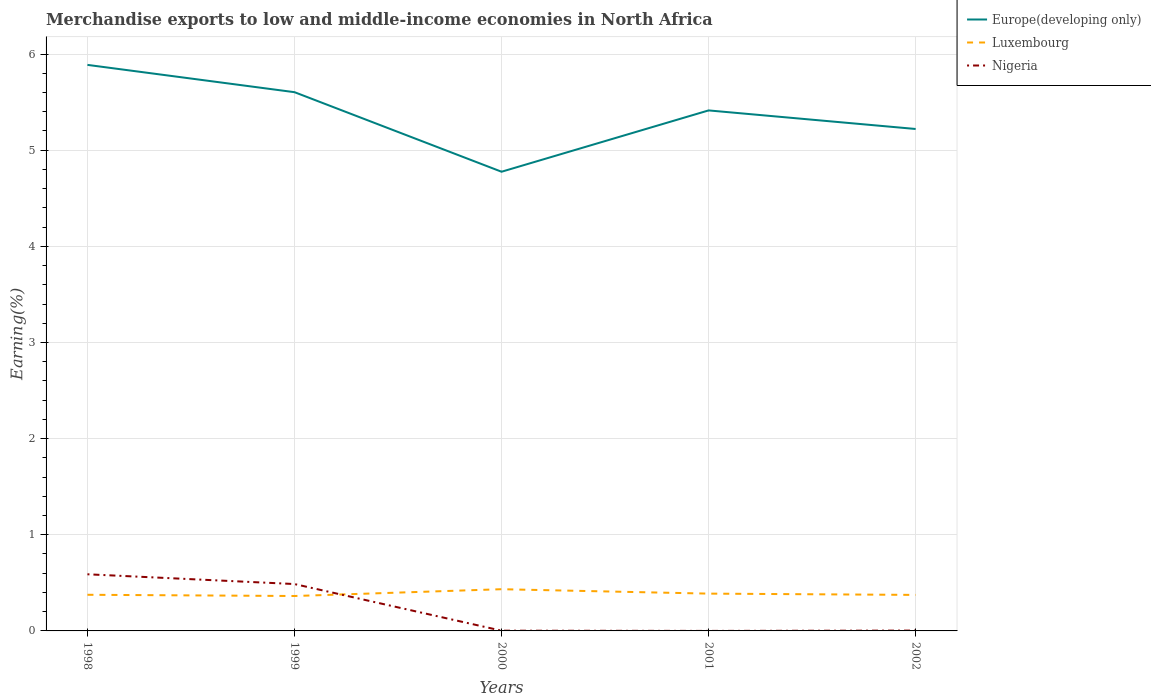How many different coloured lines are there?
Offer a terse response. 3. Is the number of lines equal to the number of legend labels?
Keep it short and to the point. Yes. Across all years, what is the maximum percentage of amount earned from merchandise exports in Luxembourg?
Provide a succinct answer. 0.36. In which year was the percentage of amount earned from merchandise exports in Luxembourg maximum?
Ensure brevity in your answer.  1999. What is the total percentage of amount earned from merchandise exports in Europe(developing only) in the graph?
Offer a terse response. -0.64. What is the difference between the highest and the second highest percentage of amount earned from merchandise exports in Europe(developing only)?
Your response must be concise. 1.11. Is the percentage of amount earned from merchandise exports in Luxembourg strictly greater than the percentage of amount earned from merchandise exports in Nigeria over the years?
Offer a very short reply. No. How many lines are there?
Offer a terse response. 3. What is the difference between two consecutive major ticks on the Y-axis?
Offer a terse response. 1. Are the values on the major ticks of Y-axis written in scientific E-notation?
Keep it short and to the point. No. Does the graph contain any zero values?
Provide a succinct answer. No. How many legend labels are there?
Keep it short and to the point. 3. How are the legend labels stacked?
Provide a succinct answer. Vertical. What is the title of the graph?
Make the answer very short. Merchandise exports to low and middle-income economies in North Africa. Does "High income" appear as one of the legend labels in the graph?
Offer a very short reply. No. What is the label or title of the Y-axis?
Give a very brief answer. Earning(%). What is the Earning(%) of Europe(developing only) in 1998?
Ensure brevity in your answer.  5.89. What is the Earning(%) of Luxembourg in 1998?
Give a very brief answer. 0.38. What is the Earning(%) in Nigeria in 1998?
Offer a terse response. 0.59. What is the Earning(%) in Europe(developing only) in 1999?
Your answer should be compact. 5.6. What is the Earning(%) of Luxembourg in 1999?
Make the answer very short. 0.36. What is the Earning(%) of Nigeria in 1999?
Provide a short and direct response. 0.49. What is the Earning(%) of Europe(developing only) in 2000?
Your answer should be compact. 4.78. What is the Earning(%) in Luxembourg in 2000?
Make the answer very short. 0.43. What is the Earning(%) in Nigeria in 2000?
Offer a terse response. 0. What is the Earning(%) in Europe(developing only) in 2001?
Offer a terse response. 5.41. What is the Earning(%) of Luxembourg in 2001?
Make the answer very short. 0.39. What is the Earning(%) in Nigeria in 2001?
Your response must be concise. 9.03093325320677e-5. What is the Earning(%) of Europe(developing only) in 2002?
Your response must be concise. 5.22. What is the Earning(%) in Luxembourg in 2002?
Give a very brief answer. 0.37. What is the Earning(%) in Nigeria in 2002?
Provide a short and direct response. 0. Across all years, what is the maximum Earning(%) of Europe(developing only)?
Make the answer very short. 5.89. Across all years, what is the maximum Earning(%) in Luxembourg?
Your answer should be compact. 0.43. Across all years, what is the maximum Earning(%) of Nigeria?
Ensure brevity in your answer.  0.59. Across all years, what is the minimum Earning(%) of Europe(developing only)?
Your answer should be compact. 4.78. Across all years, what is the minimum Earning(%) of Luxembourg?
Offer a terse response. 0.36. Across all years, what is the minimum Earning(%) of Nigeria?
Provide a succinct answer. 9.03093325320677e-5. What is the total Earning(%) in Europe(developing only) in the graph?
Your response must be concise. 26.9. What is the total Earning(%) in Luxembourg in the graph?
Provide a short and direct response. 1.94. What is the total Earning(%) in Nigeria in the graph?
Ensure brevity in your answer.  1.08. What is the difference between the Earning(%) of Europe(developing only) in 1998 and that in 1999?
Your answer should be very brief. 0.28. What is the difference between the Earning(%) in Luxembourg in 1998 and that in 1999?
Your response must be concise. 0.01. What is the difference between the Earning(%) in Nigeria in 1998 and that in 1999?
Ensure brevity in your answer.  0.1. What is the difference between the Earning(%) in Europe(developing only) in 1998 and that in 2000?
Offer a terse response. 1.11. What is the difference between the Earning(%) of Luxembourg in 1998 and that in 2000?
Your response must be concise. -0.06. What is the difference between the Earning(%) of Nigeria in 1998 and that in 2000?
Make the answer very short. 0.59. What is the difference between the Earning(%) of Europe(developing only) in 1998 and that in 2001?
Your response must be concise. 0.47. What is the difference between the Earning(%) of Luxembourg in 1998 and that in 2001?
Keep it short and to the point. -0.01. What is the difference between the Earning(%) in Nigeria in 1998 and that in 2001?
Provide a short and direct response. 0.59. What is the difference between the Earning(%) of Luxembourg in 1998 and that in 2002?
Give a very brief answer. 0. What is the difference between the Earning(%) in Nigeria in 1998 and that in 2002?
Give a very brief answer. 0.59. What is the difference between the Earning(%) of Europe(developing only) in 1999 and that in 2000?
Provide a succinct answer. 0.83. What is the difference between the Earning(%) of Luxembourg in 1999 and that in 2000?
Give a very brief answer. -0.07. What is the difference between the Earning(%) in Nigeria in 1999 and that in 2000?
Make the answer very short. 0.49. What is the difference between the Earning(%) of Europe(developing only) in 1999 and that in 2001?
Provide a succinct answer. 0.19. What is the difference between the Earning(%) of Luxembourg in 1999 and that in 2001?
Your answer should be compact. -0.02. What is the difference between the Earning(%) in Nigeria in 1999 and that in 2001?
Ensure brevity in your answer.  0.49. What is the difference between the Earning(%) in Europe(developing only) in 1999 and that in 2002?
Provide a succinct answer. 0.38. What is the difference between the Earning(%) of Luxembourg in 1999 and that in 2002?
Offer a terse response. -0.01. What is the difference between the Earning(%) of Nigeria in 1999 and that in 2002?
Give a very brief answer. 0.48. What is the difference between the Earning(%) of Europe(developing only) in 2000 and that in 2001?
Make the answer very short. -0.64. What is the difference between the Earning(%) of Luxembourg in 2000 and that in 2001?
Your response must be concise. 0.05. What is the difference between the Earning(%) of Nigeria in 2000 and that in 2001?
Provide a succinct answer. 0. What is the difference between the Earning(%) in Europe(developing only) in 2000 and that in 2002?
Your response must be concise. -0.44. What is the difference between the Earning(%) in Luxembourg in 2000 and that in 2002?
Offer a terse response. 0.06. What is the difference between the Earning(%) of Nigeria in 2000 and that in 2002?
Keep it short and to the point. -0. What is the difference between the Earning(%) of Europe(developing only) in 2001 and that in 2002?
Provide a short and direct response. 0.19. What is the difference between the Earning(%) of Luxembourg in 2001 and that in 2002?
Offer a terse response. 0.01. What is the difference between the Earning(%) in Nigeria in 2001 and that in 2002?
Keep it short and to the point. -0. What is the difference between the Earning(%) in Europe(developing only) in 1998 and the Earning(%) in Luxembourg in 1999?
Provide a short and direct response. 5.52. What is the difference between the Earning(%) of Europe(developing only) in 1998 and the Earning(%) of Nigeria in 1999?
Offer a terse response. 5.4. What is the difference between the Earning(%) of Luxembourg in 1998 and the Earning(%) of Nigeria in 1999?
Your response must be concise. -0.11. What is the difference between the Earning(%) of Europe(developing only) in 1998 and the Earning(%) of Luxembourg in 2000?
Provide a short and direct response. 5.45. What is the difference between the Earning(%) in Europe(developing only) in 1998 and the Earning(%) in Nigeria in 2000?
Provide a succinct answer. 5.88. What is the difference between the Earning(%) of Luxembourg in 1998 and the Earning(%) of Nigeria in 2000?
Give a very brief answer. 0.37. What is the difference between the Earning(%) of Europe(developing only) in 1998 and the Earning(%) of Luxembourg in 2001?
Your answer should be very brief. 5.5. What is the difference between the Earning(%) of Europe(developing only) in 1998 and the Earning(%) of Nigeria in 2001?
Your answer should be compact. 5.89. What is the difference between the Earning(%) in Luxembourg in 1998 and the Earning(%) in Nigeria in 2001?
Provide a short and direct response. 0.38. What is the difference between the Earning(%) of Europe(developing only) in 1998 and the Earning(%) of Luxembourg in 2002?
Offer a terse response. 5.51. What is the difference between the Earning(%) of Europe(developing only) in 1998 and the Earning(%) of Nigeria in 2002?
Give a very brief answer. 5.88. What is the difference between the Earning(%) in Luxembourg in 1998 and the Earning(%) in Nigeria in 2002?
Keep it short and to the point. 0.37. What is the difference between the Earning(%) of Europe(developing only) in 1999 and the Earning(%) of Luxembourg in 2000?
Give a very brief answer. 5.17. What is the difference between the Earning(%) of Europe(developing only) in 1999 and the Earning(%) of Nigeria in 2000?
Keep it short and to the point. 5.6. What is the difference between the Earning(%) in Luxembourg in 1999 and the Earning(%) in Nigeria in 2000?
Provide a succinct answer. 0.36. What is the difference between the Earning(%) of Europe(developing only) in 1999 and the Earning(%) of Luxembourg in 2001?
Offer a terse response. 5.22. What is the difference between the Earning(%) in Europe(developing only) in 1999 and the Earning(%) in Nigeria in 2001?
Give a very brief answer. 5.6. What is the difference between the Earning(%) in Luxembourg in 1999 and the Earning(%) in Nigeria in 2001?
Your answer should be compact. 0.36. What is the difference between the Earning(%) of Europe(developing only) in 1999 and the Earning(%) of Luxembourg in 2002?
Your answer should be very brief. 5.23. What is the difference between the Earning(%) of Europe(developing only) in 1999 and the Earning(%) of Nigeria in 2002?
Keep it short and to the point. 5.6. What is the difference between the Earning(%) in Luxembourg in 1999 and the Earning(%) in Nigeria in 2002?
Make the answer very short. 0.36. What is the difference between the Earning(%) of Europe(developing only) in 2000 and the Earning(%) of Luxembourg in 2001?
Provide a short and direct response. 4.39. What is the difference between the Earning(%) in Europe(developing only) in 2000 and the Earning(%) in Nigeria in 2001?
Your response must be concise. 4.78. What is the difference between the Earning(%) of Luxembourg in 2000 and the Earning(%) of Nigeria in 2001?
Your response must be concise. 0.43. What is the difference between the Earning(%) of Europe(developing only) in 2000 and the Earning(%) of Luxembourg in 2002?
Offer a very short reply. 4.4. What is the difference between the Earning(%) in Europe(developing only) in 2000 and the Earning(%) in Nigeria in 2002?
Keep it short and to the point. 4.77. What is the difference between the Earning(%) of Luxembourg in 2000 and the Earning(%) of Nigeria in 2002?
Provide a short and direct response. 0.43. What is the difference between the Earning(%) in Europe(developing only) in 2001 and the Earning(%) in Luxembourg in 2002?
Keep it short and to the point. 5.04. What is the difference between the Earning(%) in Europe(developing only) in 2001 and the Earning(%) in Nigeria in 2002?
Your answer should be compact. 5.41. What is the difference between the Earning(%) of Luxembourg in 2001 and the Earning(%) of Nigeria in 2002?
Give a very brief answer. 0.38. What is the average Earning(%) in Europe(developing only) per year?
Your answer should be very brief. 5.38. What is the average Earning(%) of Luxembourg per year?
Make the answer very short. 0.39. What is the average Earning(%) of Nigeria per year?
Keep it short and to the point. 0.22. In the year 1998, what is the difference between the Earning(%) of Europe(developing only) and Earning(%) of Luxembourg?
Ensure brevity in your answer.  5.51. In the year 1998, what is the difference between the Earning(%) in Europe(developing only) and Earning(%) in Nigeria?
Offer a terse response. 5.3. In the year 1998, what is the difference between the Earning(%) in Luxembourg and Earning(%) in Nigeria?
Ensure brevity in your answer.  -0.21. In the year 1999, what is the difference between the Earning(%) of Europe(developing only) and Earning(%) of Luxembourg?
Provide a short and direct response. 5.24. In the year 1999, what is the difference between the Earning(%) of Europe(developing only) and Earning(%) of Nigeria?
Your answer should be very brief. 5.12. In the year 1999, what is the difference between the Earning(%) in Luxembourg and Earning(%) in Nigeria?
Provide a succinct answer. -0.12. In the year 2000, what is the difference between the Earning(%) of Europe(developing only) and Earning(%) of Luxembourg?
Ensure brevity in your answer.  4.34. In the year 2000, what is the difference between the Earning(%) in Europe(developing only) and Earning(%) in Nigeria?
Your answer should be compact. 4.77. In the year 2000, what is the difference between the Earning(%) of Luxembourg and Earning(%) of Nigeria?
Offer a very short reply. 0.43. In the year 2001, what is the difference between the Earning(%) of Europe(developing only) and Earning(%) of Luxembourg?
Your response must be concise. 5.03. In the year 2001, what is the difference between the Earning(%) in Europe(developing only) and Earning(%) in Nigeria?
Keep it short and to the point. 5.41. In the year 2001, what is the difference between the Earning(%) in Luxembourg and Earning(%) in Nigeria?
Your response must be concise. 0.39. In the year 2002, what is the difference between the Earning(%) of Europe(developing only) and Earning(%) of Luxembourg?
Provide a succinct answer. 4.85. In the year 2002, what is the difference between the Earning(%) of Europe(developing only) and Earning(%) of Nigeria?
Keep it short and to the point. 5.22. In the year 2002, what is the difference between the Earning(%) of Luxembourg and Earning(%) of Nigeria?
Ensure brevity in your answer.  0.37. What is the ratio of the Earning(%) of Europe(developing only) in 1998 to that in 1999?
Provide a short and direct response. 1.05. What is the ratio of the Earning(%) in Luxembourg in 1998 to that in 1999?
Provide a short and direct response. 1.04. What is the ratio of the Earning(%) in Nigeria in 1998 to that in 1999?
Your answer should be very brief. 1.21. What is the ratio of the Earning(%) of Europe(developing only) in 1998 to that in 2000?
Make the answer very short. 1.23. What is the ratio of the Earning(%) of Luxembourg in 1998 to that in 2000?
Offer a very short reply. 0.87. What is the ratio of the Earning(%) in Nigeria in 1998 to that in 2000?
Ensure brevity in your answer.  243.67. What is the ratio of the Earning(%) in Europe(developing only) in 1998 to that in 2001?
Provide a succinct answer. 1.09. What is the ratio of the Earning(%) in Luxembourg in 1998 to that in 2001?
Your answer should be very brief. 0.97. What is the ratio of the Earning(%) of Nigeria in 1998 to that in 2001?
Provide a short and direct response. 6522.78. What is the ratio of the Earning(%) of Europe(developing only) in 1998 to that in 2002?
Provide a succinct answer. 1.13. What is the ratio of the Earning(%) of Nigeria in 1998 to that in 2002?
Offer a very short reply. 169.07. What is the ratio of the Earning(%) of Europe(developing only) in 1999 to that in 2000?
Provide a succinct answer. 1.17. What is the ratio of the Earning(%) in Luxembourg in 1999 to that in 2000?
Make the answer very short. 0.84. What is the ratio of the Earning(%) of Nigeria in 1999 to that in 2000?
Give a very brief answer. 201.65. What is the ratio of the Earning(%) of Europe(developing only) in 1999 to that in 2001?
Your answer should be very brief. 1.03. What is the ratio of the Earning(%) in Luxembourg in 1999 to that in 2001?
Offer a very short reply. 0.94. What is the ratio of the Earning(%) of Nigeria in 1999 to that in 2001?
Provide a succinct answer. 5397.85. What is the ratio of the Earning(%) in Europe(developing only) in 1999 to that in 2002?
Provide a succinct answer. 1.07. What is the ratio of the Earning(%) in Luxembourg in 1999 to that in 2002?
Your answer should be very brief. 0.97. What is the ratio of the Earning(%) of Nigeria in 1999 to that in 2002?
Your answer should be very brief. 139.91. What is the ratio of the Earning(%) of Europe(developing only) in 2000 to that in 2001?
Make the answer very short. 0.88. What is the ratio of the Earning(%) of Luxembourg in 2000 to that in 2001?
Give a very brief answer. 1.12. What is the ratio of the Earning(%) of Nigeria in 2000 to that in 2001?
Keep it short and to the point. 26.77. What is the ratio of the Earning(%) of Europe(developing only) in 2000 to that in 2002?
Provide a short and direct response. 0.91. What is the ratio of the Earning(%) of Luxembourg in 2000 to that in 2002?
Make the answer very short. 1.16. What is the ratio of the Earning(%) in Nigeria in 2000 to that in 2002?
Your response must be concise. 0.69. What is the ratio of the Earning(%) of Luxembourg in 2001 to that in 2002?
Your answer should be very brief. 1.04. What is the ratio of the Earning(%) in Nigeria in 2001 to that in 2002?
Offer a very short reply. 0.03. What is the difference between the highest and the second highest Earning(%) in Europe(developing only)?
Provide a succinct answer. 0.28. What is the difference between the highest and the second highest Earning(%) of Luxembourg?
Provide a short and direct response. 0.05. What is the difference between the highest and the second highest Earning(%) in Nigeria?
Ensure brevity in your answer.  0.1. What is the difference between the highest and the lowest Earning(%) of Europe(developing only)?
Keep it short and to the point. 1.11. What is the difference between the highest and the lowest Earning(%) in Luxembourg?
Give a very brief answer. 0.07. What is the difference between the highest and the lowest Earning(%) in Nigeria?
Provide a short and direct response. 0.59. 